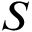Convert formula to latex. <formula><loc_0><loc_0><loc_500><loc_500>S</formula> 